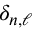<formula> <loc_0><loc_0><loc_500><loc_500>\delta _ { n , \ell }</formula> 